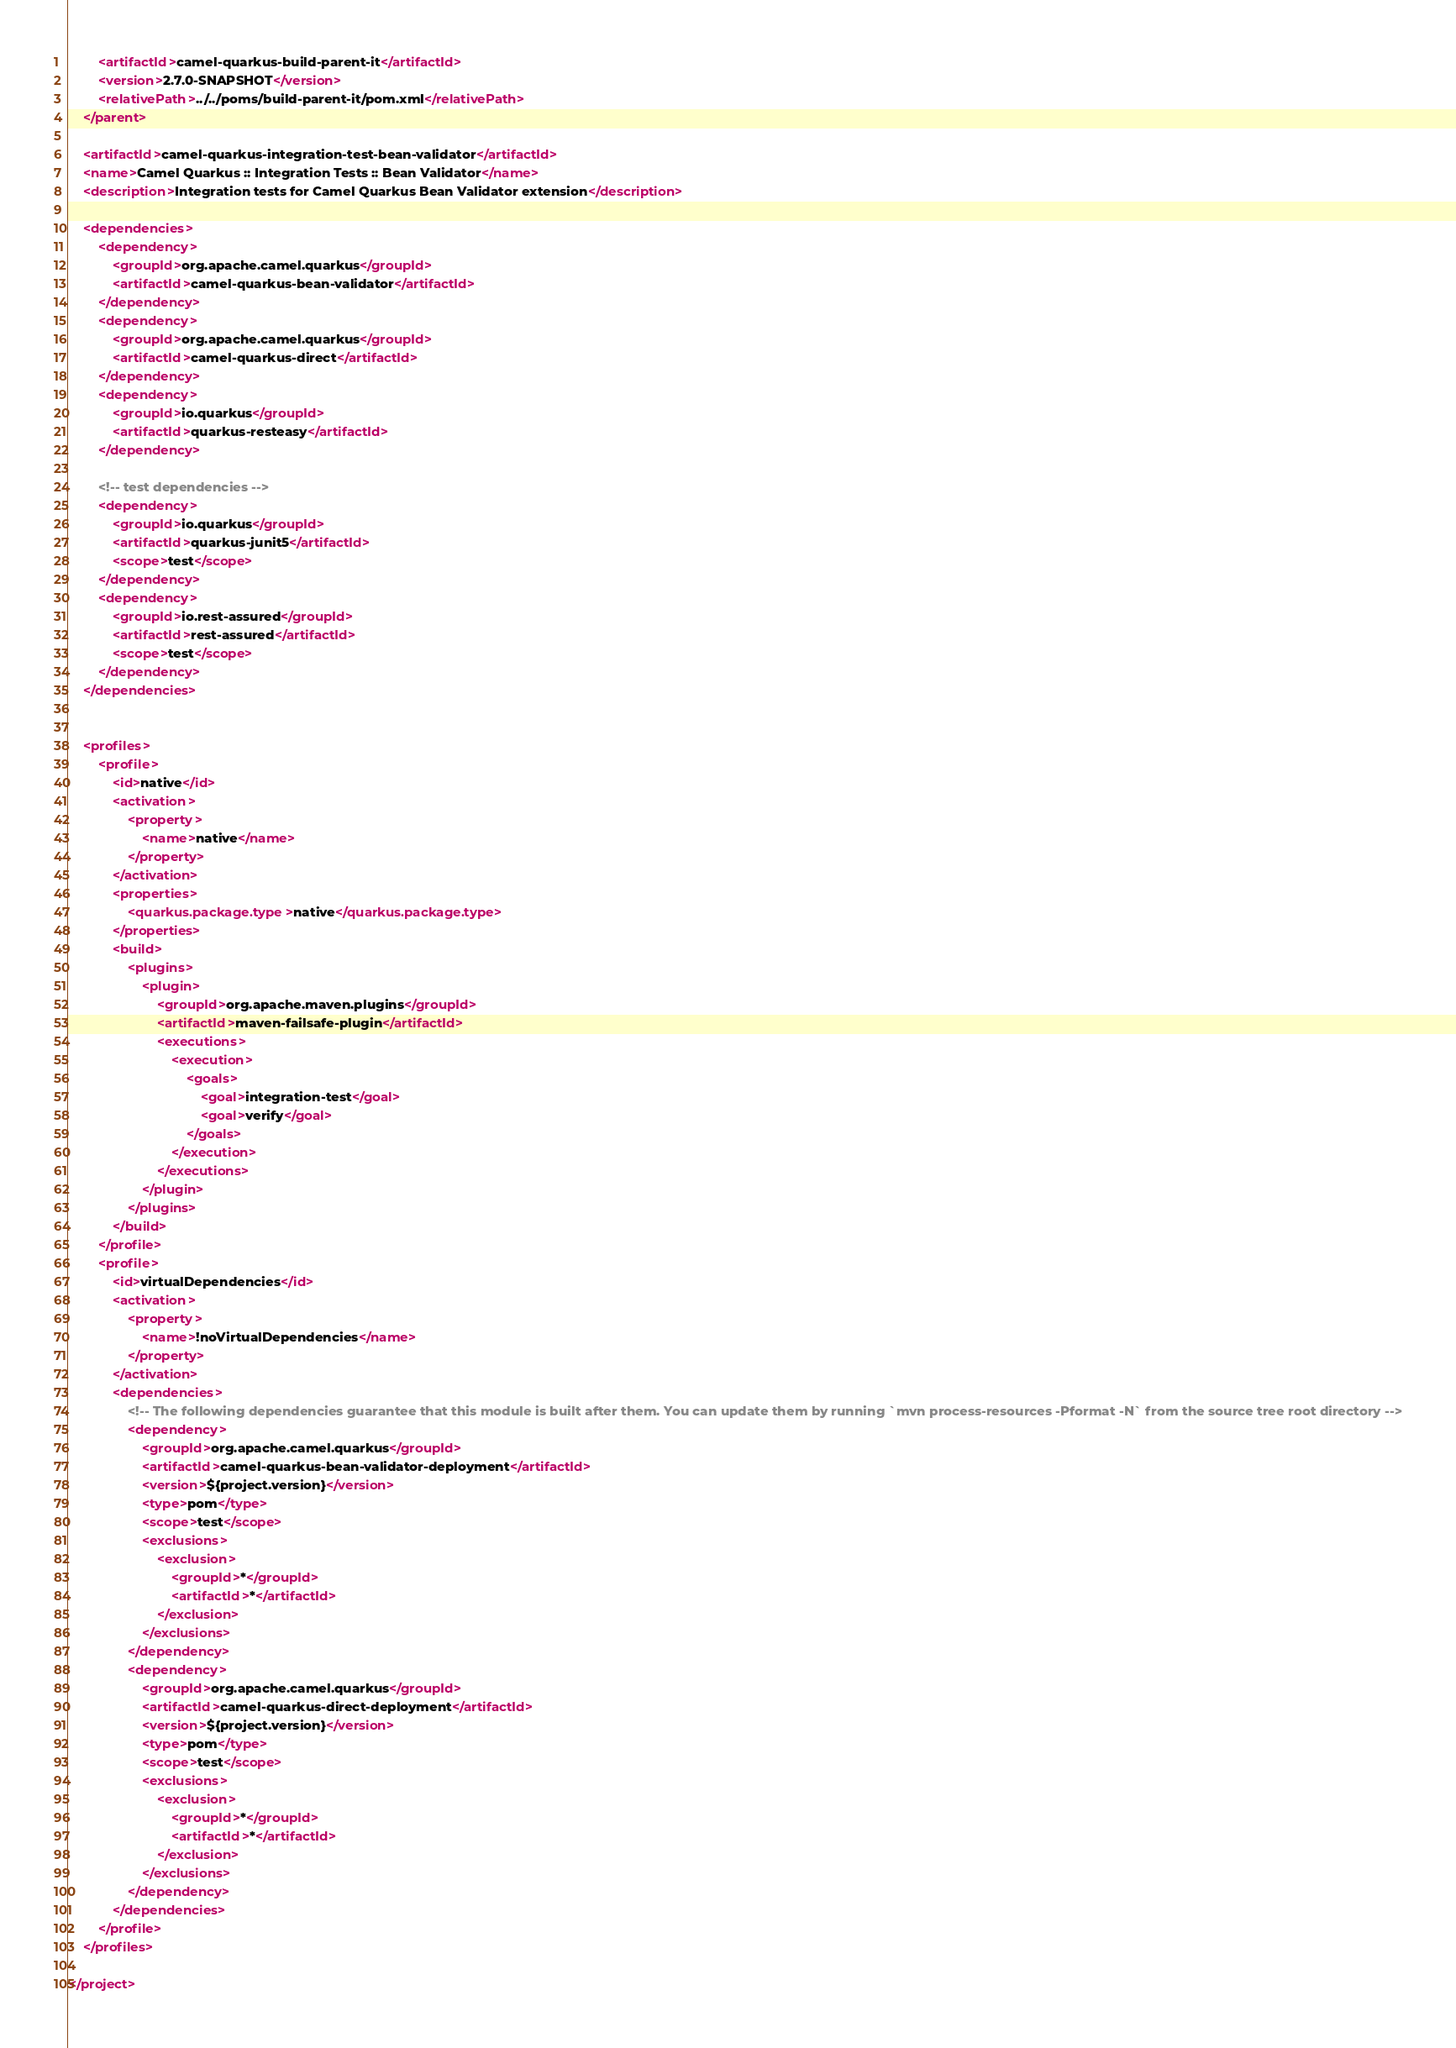<code> <loc_0><loc_0><loc_500><loc_500><_XML_>        <artifactId>camel-quarkus-build-parent-it</artifactId>
        <version>2.7.0-SNAPSHOT</version>
        <relativePath>../../poms/build-parent-it/pom.xml</relativePath>
    </parent>

    <artifactId>camel-quarkus-integration-test-bean-validator</artifactId>
    <name>Camel Quarkus :: Integration Tests :: Bean Validator</name>
    <description>Integration tests for Camel Quarkus Bean Validator extension</description>

    <dependencies>
        <dependency>
            <groupId>org.apache.camel.quarkus</groupId>
            <artifactId>camel-quarkus-bean-validator</artifactId>
        </dependency>
        <dependency>
            <groupId>org.apache.camel.quarkus</groupId>
            <artifactId>camel-quarkus-direct</artifactId>
        </dependency>
        <dependency>
            <groupId>io.quarkus</groupId>
            <artifactId>quarkus-resteasy</artifactId>
        </dependency>

        <!-- test dependencies -->
        <dependency>
            <groupId>io.quarkus</groupId>
            <artifactId>quarkus-junit5</artifactId>
            <scope>test</scope>
        </dependency>
        <dependency>
            <groupId>io.rest-assured</groupId>
            <artifactId>rest-assured</artifactId>
            <scope>test</scope>
        </dependency>
    </dependencies>


    <profiles>
        <profile>
            <id>native</id>
            <activation>
                <property>
                    <name>native</name>
                </property>
            </activation>
            <properties>
                <quarkus.package.type>native</quarkus.package.type>
            </properties>
            <build>
                <plugins>
                    <plugin>
                        <groupId>org.apache.maven.plugins</groupId>
                        <artifactId>maven-failsafe-plugin</artifactId>
                        <executions>
                            <execution>
                                <goals>
                                    <goal>integration-test</goal>
                                    <goal>verify</goal>
                                </goals>
                            </execution>
                        </executions>
                    </plugin>
                </plugins>
            </build>
        </profile>
        <profile>
            <id>virtualDependencies</id>
            <activation>
                <property>
                    <name>!noVirtualDependencies</name>
                </property>
            </activation>
            <dependencies>
                <!-- The following dependencies guarantee that this module is built after them. You can update them by running `mvn process-resources -Pformat -N` from the source tree root directory -->
                <dependency>
                    <groupId>org.apache.camel.quarkus</groupId>
                    <artifactId>camel-quarkus-bean-validator-deployment</artifactId>
                    <version>${project.version}</version>
                    <type>pom</type>
                    <scope>test</scope>
                    <exclusions>
                        <exclusion>
                            <groupId>*</groupId>
                            <artifactId>*</artifactId>
                        </exclusion>
                    </exclusions>
                </dependency>
                <dependency>
                    <groupId>org.apache.camel.quarkus</groupId>
                    <artifactId>camel-quarkus-direct-deployment</artifactId>
                    <version>${project.version}</version>
                    <type>pom</type>
                    <scope>test</scope>
                    <exclusions>
                        <exclusion>
                            <groupId>*</groupId>
                            <artifactId>*</artifactId>
                        </exclusion>
                    </exclusions>
                </dependency>
            </dependencies>
        </profile>
    </profiles>

</project>
</code> 